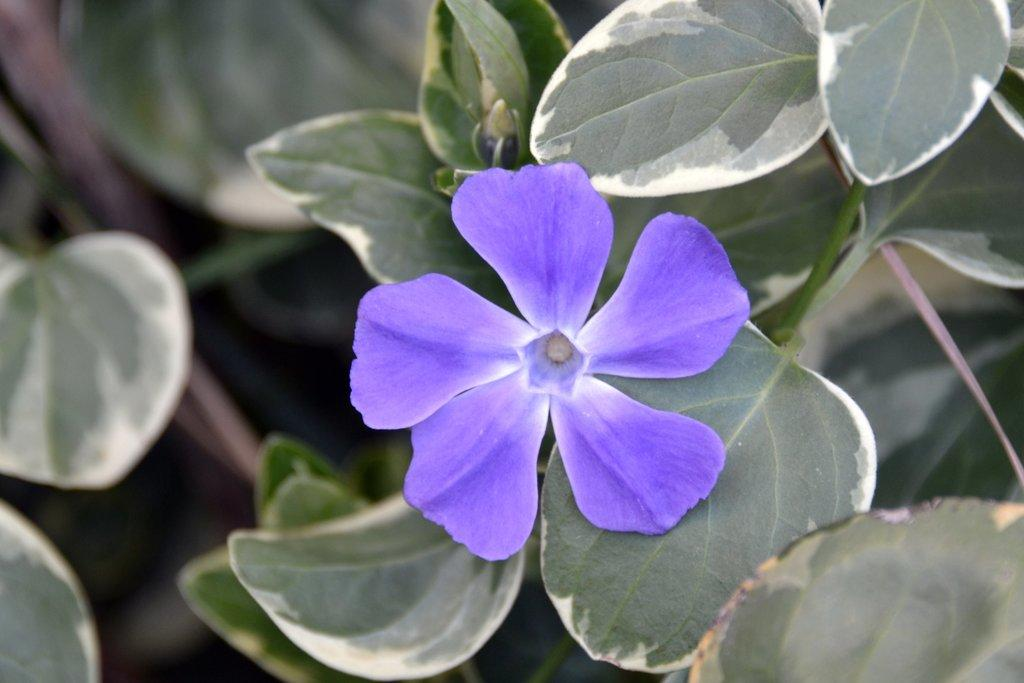What type of flower can be seen in the image? There is a violet color flower in the image. Is the flower part of a larger plant? Yes, the flower is attached to a plant. What other plants can be seen in the image? There are plants in the image. What color are the leaves of the plants in the image? There are green leaves in the image. What type of game is being played in the image? There is no game being played in the image; it features a violet color flower and plants. Can you describe the veins of the flower in the image? There is no mention of veins in the flower, as the focus is on the color and attachment to a plant. 